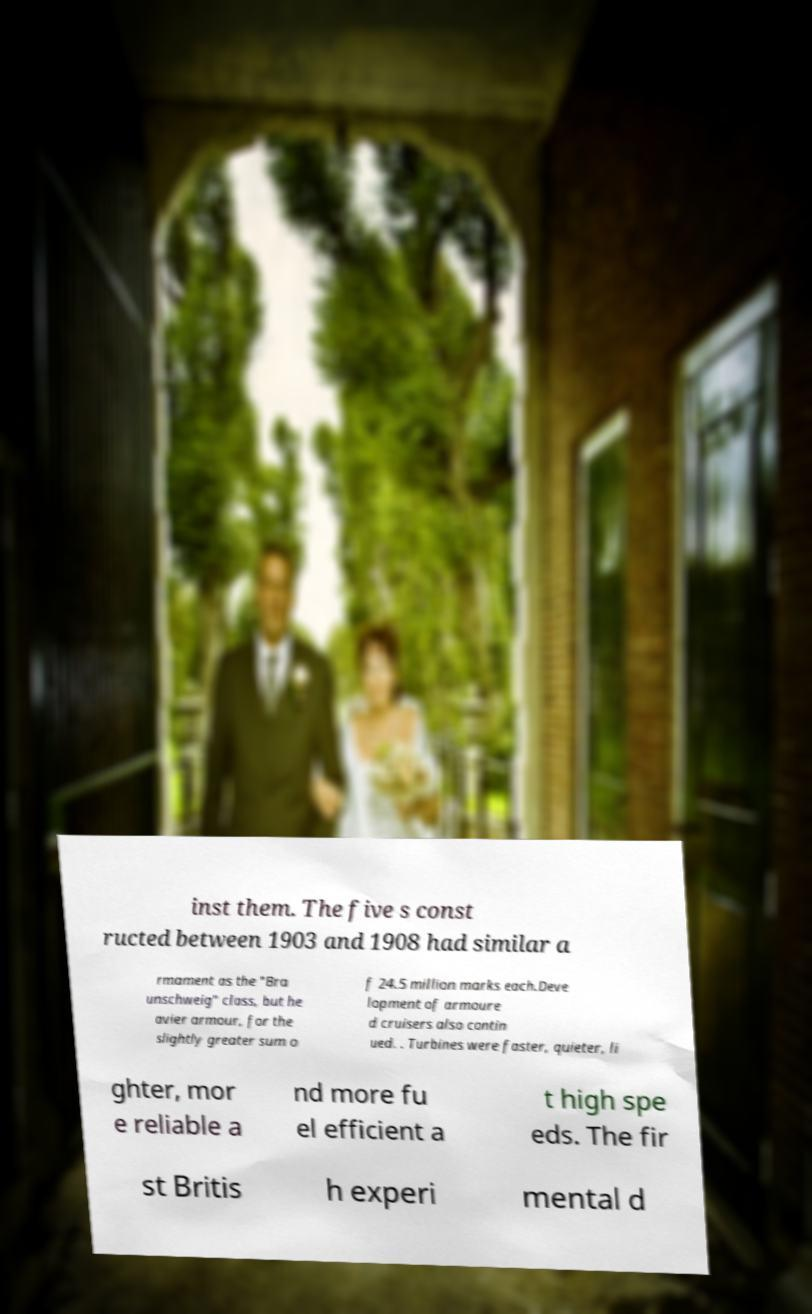Could you assist in decoding the text presented in this image and type it out clearly? inst them. The five s const ructed between 1903 and 1908 had similar a rmament as the "Bra unschweig" class, but he avier armour, for the slightly greater sum o f 24.5 million marks each.Deve lopment of armoure d cruisers also contin ued. . Turbines were faster, quieter, li ghter, mor e reliable a nd more fu el efficient a t high spe eds. The fir st Britis h experi mental d 